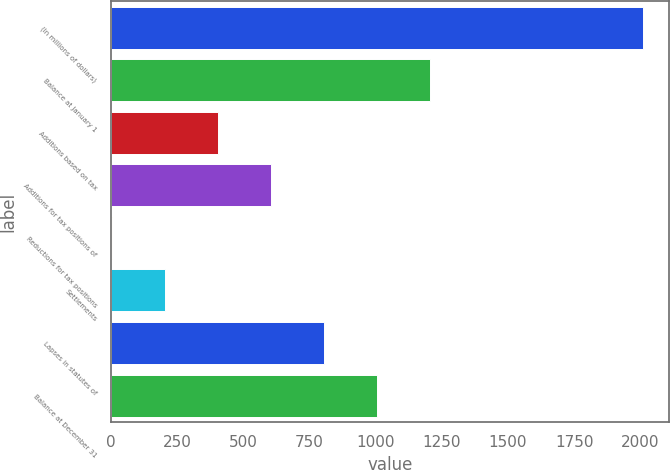Convert chart to OTSL. <chart><loc_0><loc_0><loc_500><loc_500><bar_chart><fcel>(In millions of dollars)<fcel>Balance at January 1<fcel>Additions based on tax<fcel>Additions for tax positions of<fcel>Reductions for tax positions<fcel>Settlements<fcel>Lapses in statutes of<fcel>Balance at December 31<nl><fcel>2009<fcel>1207<fcel>405<fcel>605.5<fcel>4<fcel>204.5<fcel>806<fcel>1006.5<nl></chart> 